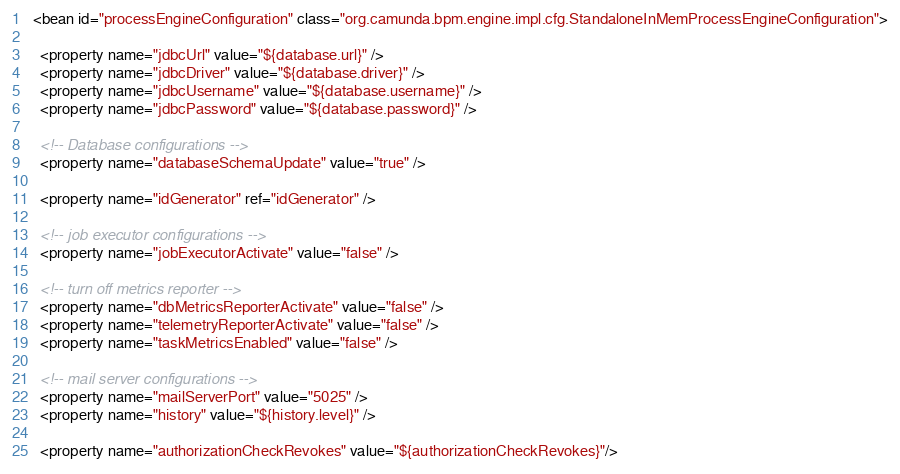<code> <loc_0><loc_0><loc_500><loc_500><_XML_>  <bean id="processEngineConfiguration" class="org.camunda.bpm.engine.impl.cfg.StandaloneInMemProcessEngineConfiguration">

    <property name="jdbcUrl" value="${database.url}" />
    <property name="jdbcDriver" value="${database.driver}" />
    <property name="jdbcUsername" value="${database.username}" />
    <property name="jdbcPassword" value="${database.password}" />

    <!-- Database configurations -->
    <property name="databaseSchemaUpdate" value="true" />

    <property name="idGenerator" ref="idGenerator" />

    <!-- job executor configurations -->
    <property name="jobExecutorActivate" value="false" />

    <!-- turn off metrics reporter -->
    <property name="dbMetricsReporterActivate" value="false" />
    <property name="telemetryReporterActivate" value="false" />
    <property name="taskMetricsEnabled" value="false" />

    <!-- mail server configurations -->
    <property name="mailServerPort" value="5025" />
    <property name="history" value="${history.level}" />

    <property name="authorizationCheckRevokes" value="${authorizationCheckRevokes}"/>
</code> 